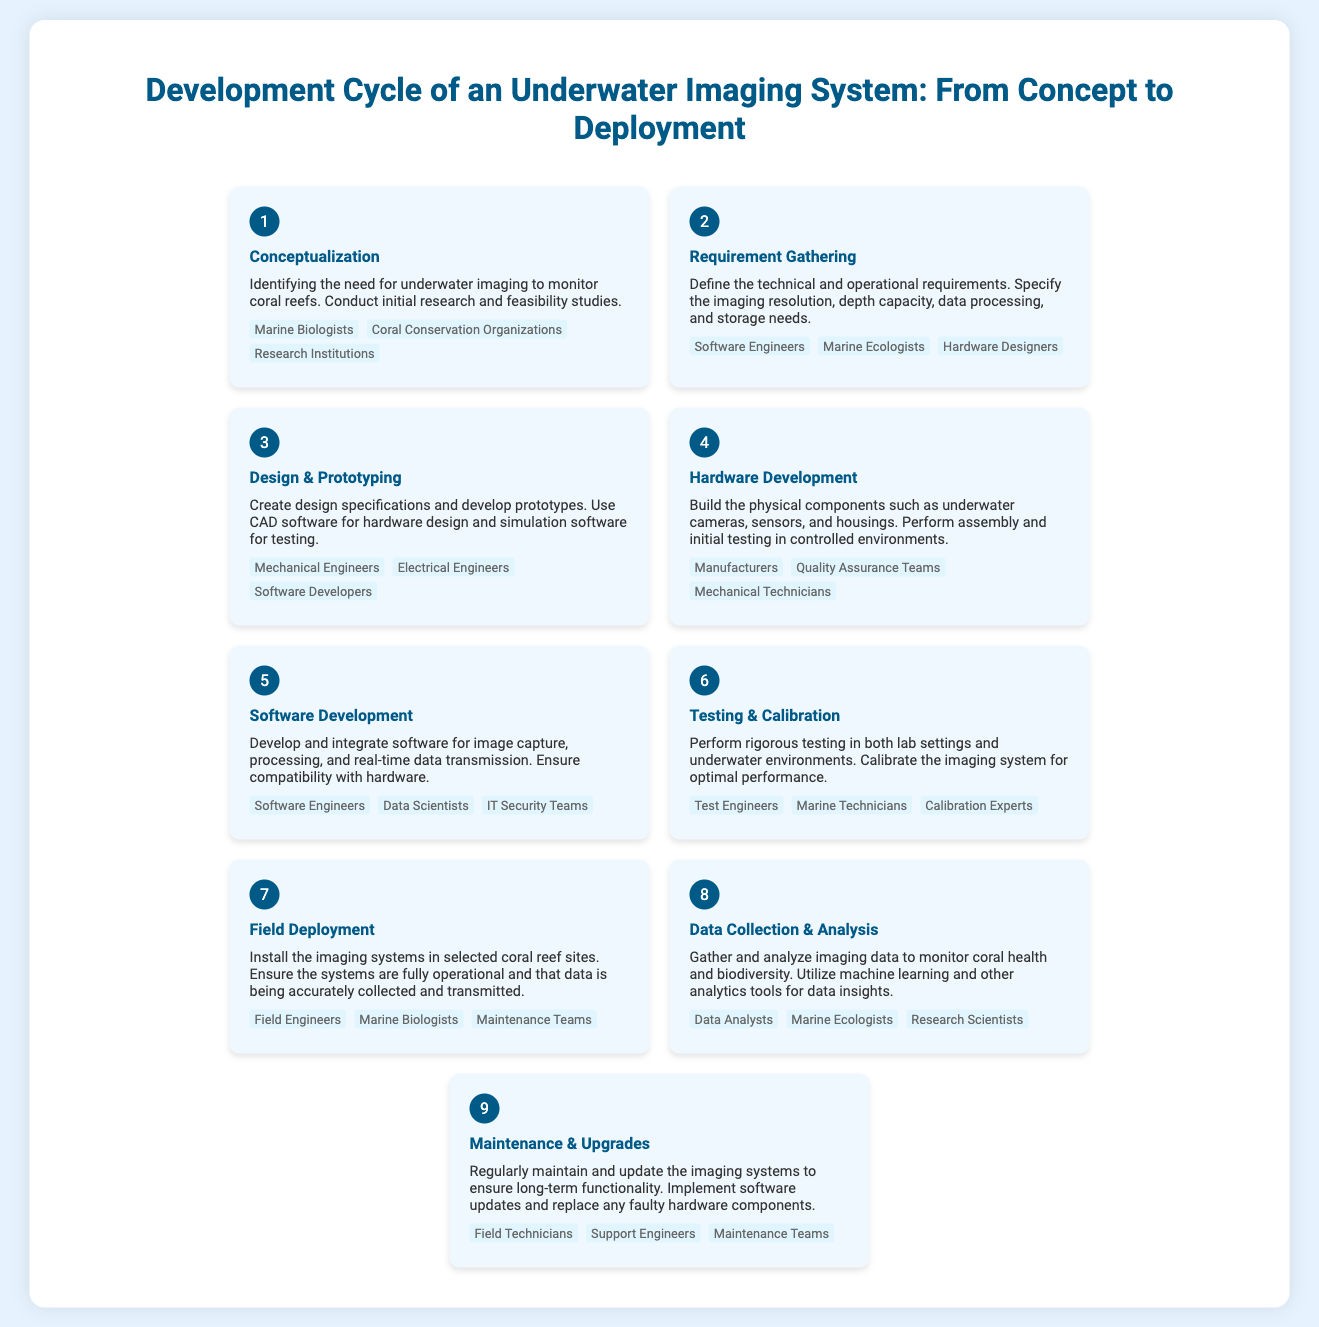What is the first step in the development cycle? The first step is conceptualization, which involves identifying the need for underwater imaging.
Answer: Conceptualization Who are involved in the requirement gathering process? The requirement gathering process includes individuals and teams that define the technical and operational requirements, such as software engineers and marine ecologists.
Answer: Software Engineers, Marine Ecologists, Hardware Designers What is created in the design and prototyping stage? In the design and prototyping stage, design specifications and prototypes are developed, using CAD software for hardware design and simulation software for testing.
Answer: Design specifications and prototypes Which key entities are involved in testing and calibration? Testing and calibration require collaboration among various experts to ensure the imaging system works optimally in both lab settings and underwater environments.
Answer: Test Engineers, Marine Technicians, Calibration Experts How many steps are there in the development cycle? The infographic outlines the entire development cycle of the underwater imaging system, specifying each stage from concept to deployment.
Answer: Nine steps What is the focus of the data collection and analysis step? The data collection and analysis step is crucial for monitoring coral health and biodiversity, and it leverages advanced analytics for insights.
Answer: Coral health and biodiversity Which role is primarily responsible for field deployment? Field deployment involves installing imaging systems at coral reef sites.
Answer: Field Engineers What phase comes after hardware development? The phase that follows hardware development is software development, which involves creating and integrating software for the imaging systems.
Answer: Software Development 